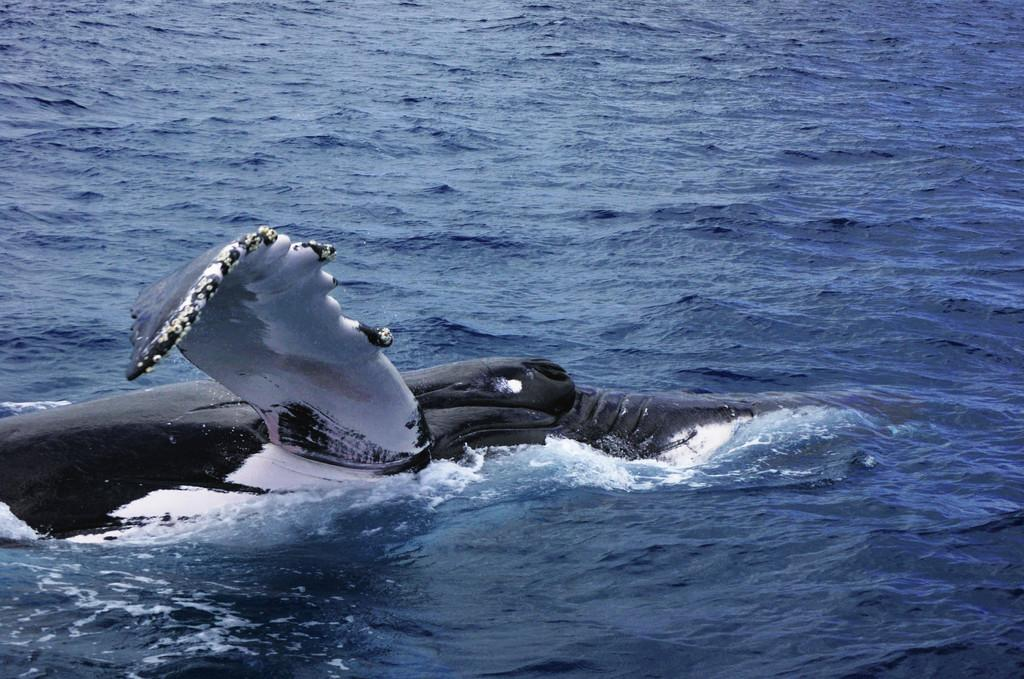What is the main subject in the center of the image? There is a whale in the center of the image. Where is the whale located? The whale is in the water. What can be seen in the background of the image? There is water visible in the background of the image. What type of plane can be seen flying in the image? There is no plane present in the image; it features a whale in the water. What kind of nut is being used for treatment in the image? There is no nut or treatment present in the image. 